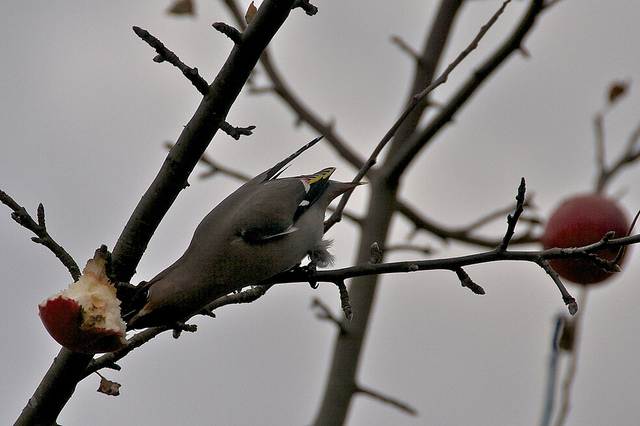<image>What kind of fowl is it? I don't know what kind of fowl it is. It could be a seagull, pigeon, bird, dove, sparrow or something else. What kind of fowl is it? I am not sure what kind of fowl it is. It can be seen seagull, pigeon, dove, sparrow or bird. 